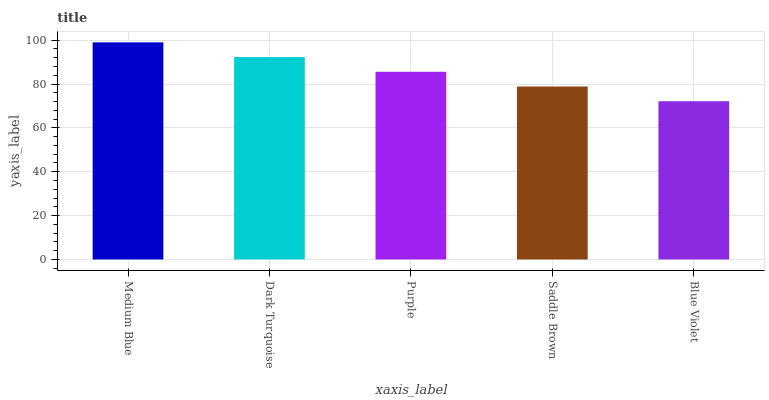Is Blue Violet the minimum?
Answer yes or no. Yes. Is Medium Blue the maximum?
Answer yes or no. Yes. Is Dark Turquoise the minimum?
Answer yes or no. No. Is Dark Turquoise the maximum?
Answer yes or no. No. Is Medium Blue greater than Dark Turquoise?
Answer yes or no. Yes. Is Dark Turquoise less than Medium Blue?
Answer yes or no. Yes. Is Dark Turquoise greater than Medium Blue?
Answer yes or no. No. Is Medium Blue less than Dark Turquoise?
Answer yes or no. No. Is Purple the high median?
Answer yes or no. Yes. Is Purple the low median?
Answer yes or no. Yes. Is Saddle Brown the high median?
Answer yes or no. No. Is Blue Violet the low median?
Answer yes or no. No. 